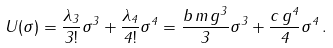Convert formula to latex. <formula><loc_0><loc_0><loc_500><loc_500>U ( \sigma ) = \frac { \lambda _ { 3 } } { 3 ! } \sigma ^ { 3 } + \frac { \lambda _ { 4 } } { 4 ! } \sigma ^ { 4 } = \frac { b \, m \, g ^ { 3 } } { 3 } \sigma ^ { 3 } + \frac { c \, g ^ { 4 } } { 4 } \sigma ^ { 4 } \, .</formula> 